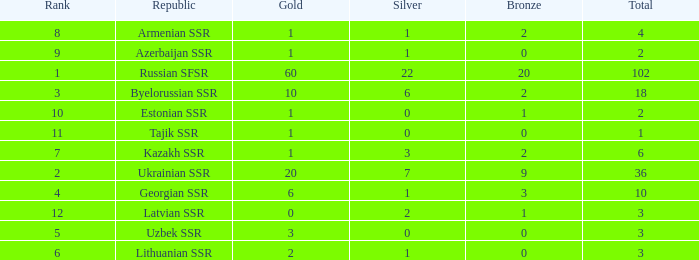What is the sum of bronzes for teams with more than 2 gold, ranked under 3, and less than 22 silver? 9.0. 